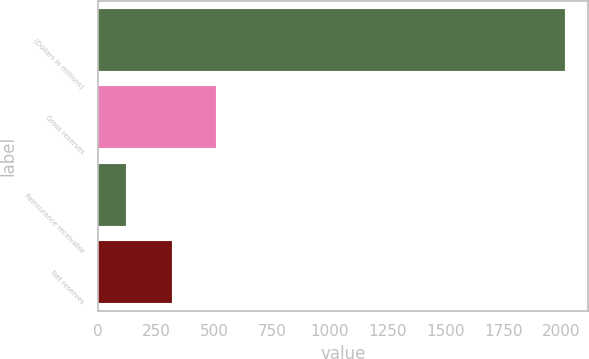<chart> <loc_0><loc_0><loc_500><loc_500><bar_chart><fcel>(Dollars in millions)<fcel>Gross reserves<fcel>Reinsurance receivable<fcel>Net reserves<nl><fcel>2016<fcel>508.5<fcel>122<fcel>319.1<nl></chart> 